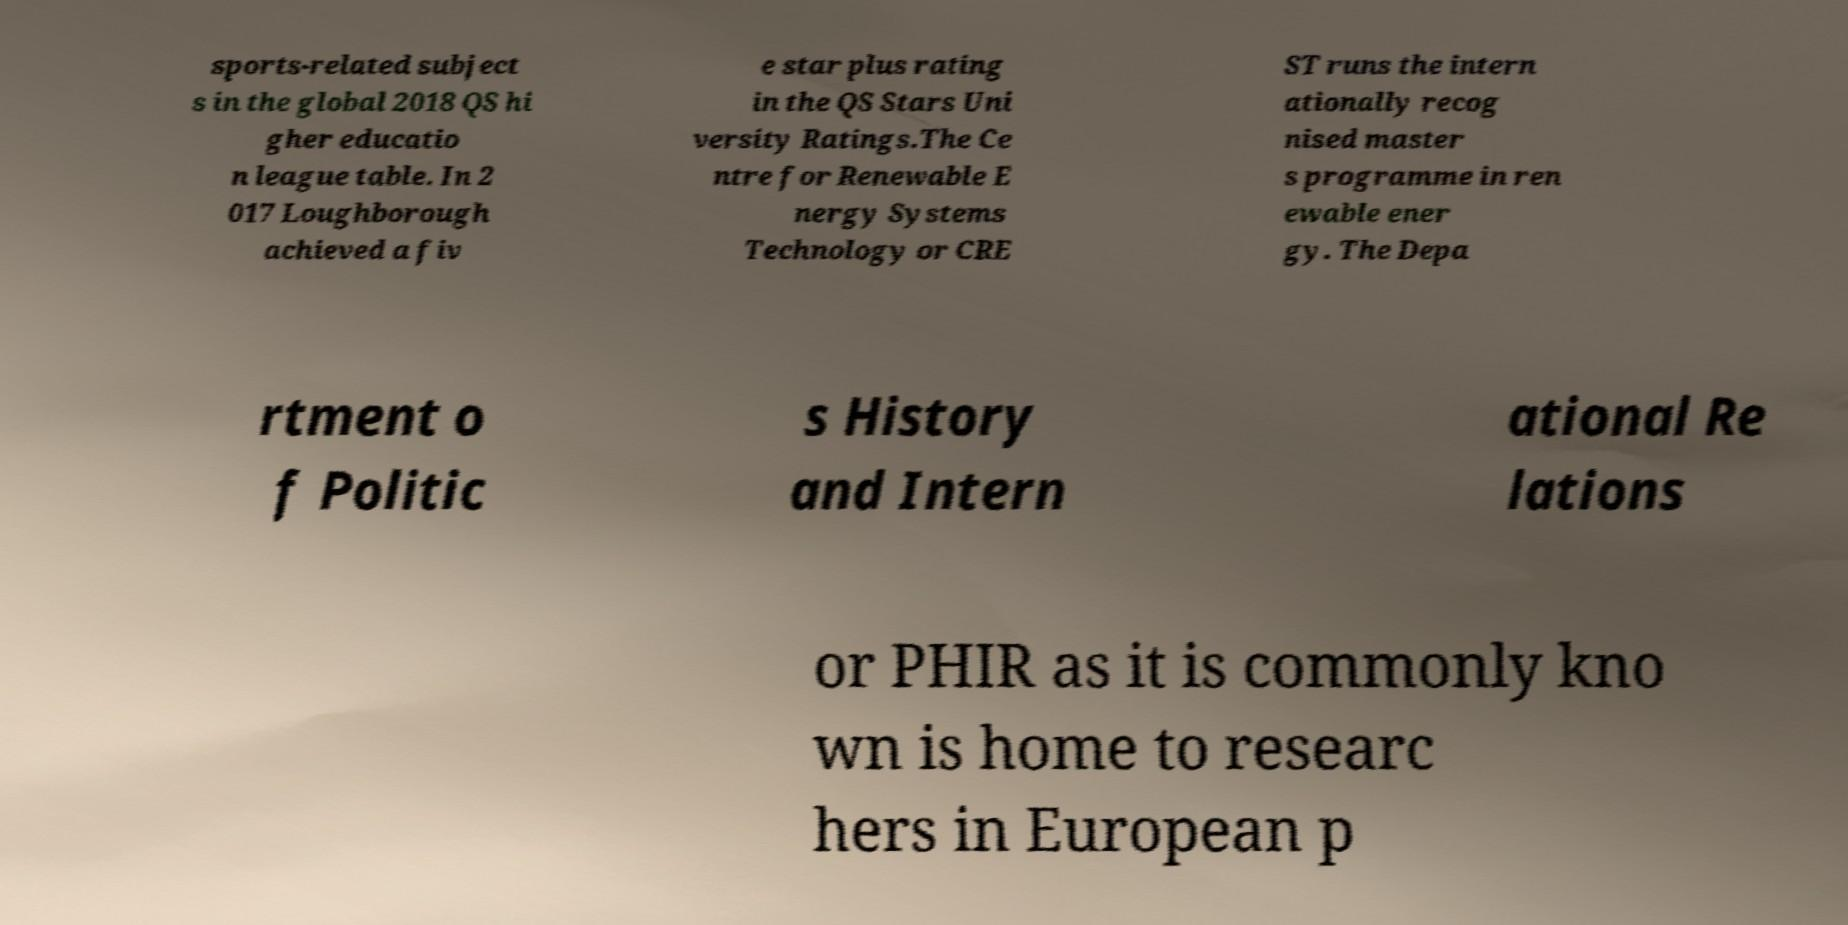There's text embedded in this image that I need extracted. Can you transcribe it verbatim? sports-related subject s in the global 2018 QS hi gher educatio n league table. In 2 017 Loughborough achieved a fiv e star plus rating in the QS Stars Uni versity Ratings.The Ce ntre for Renewable E nergy Systems Technology or CRE ST runs the intern ationally recog nised master s programme in ren ewable ener gy. The Depa rtment o f Politic s History and Intern ational Re lations or PHIR as it is commonly kno wn is home to researc hers in European p 